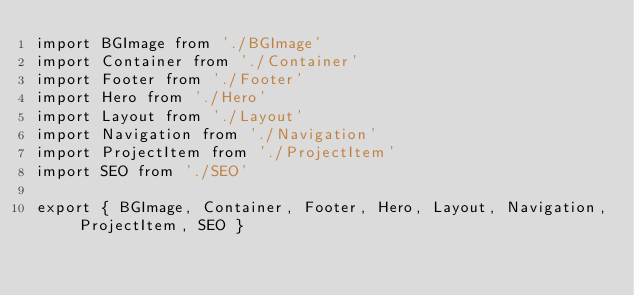Convert code to text. <code><loc_0><loc_0><loc_500><loc_500><_JavaScript_>import BGImage from './BGImage'
import Container from './Container'
import Footer from './Footer'
import Hero from './Hero'
import Layout from './Layout'
import Navigation from './Navigation'
import ProjectItem from './ProjectItem'
import SEO from './SEO'

export { BGImage, Container, Footer, Hero, Layout, Navigation, ProjectItem, SEO }
</code> 